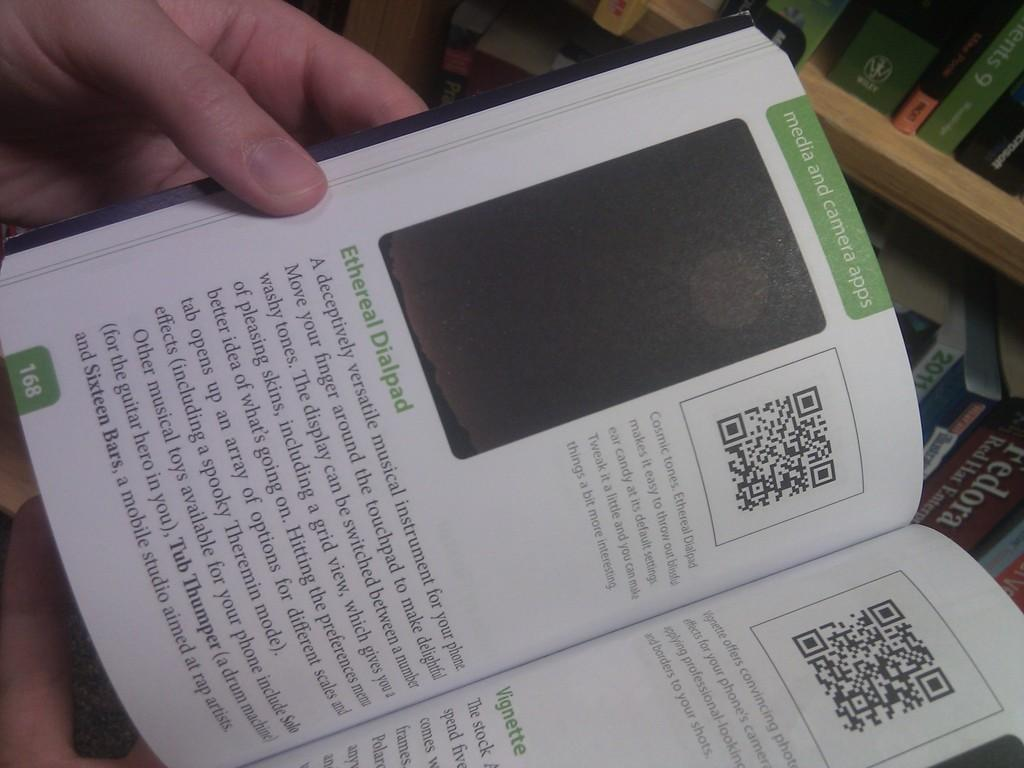Provide a one-sentence caption for the provided image. the inside of a book with the page titled: media and camera apps. 